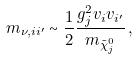Convert formula to latex. <formula><loc_0><loc_0><loc_500><loc_500>m _ { \nu , i i ^ { \prime } } \sim \frac { 1 } { 2 } \frac { g ^ { 2 } _ { j } v _ { i } v _ { i ^ { \prime } } } { m _ { \tilde { \chi } ^ { 0 } _ { j } } } \, ,</formula> 